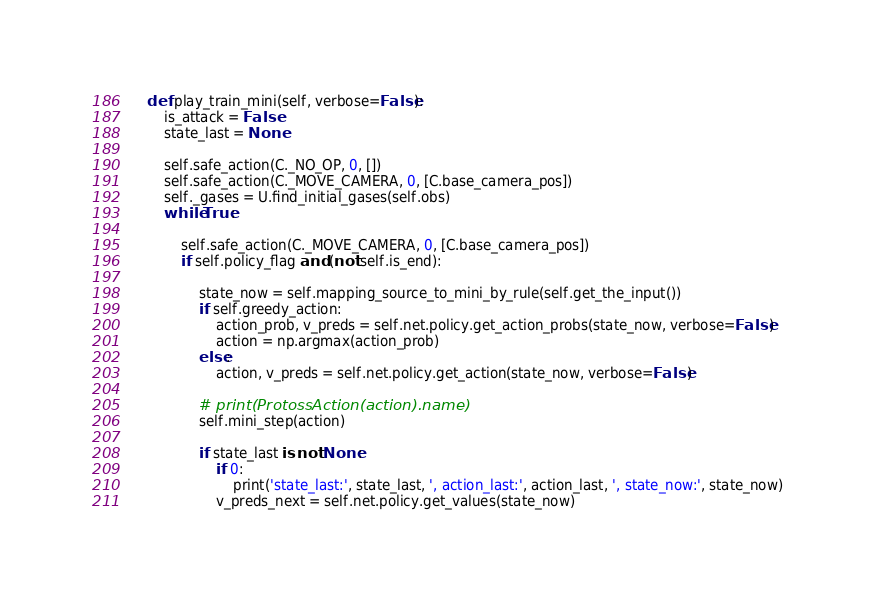<code> <loc_0><loc_0><loc_500><loc_500><_Python_>    def play_train_mini(self, verbose=False):
        is_attack = False
        state_last = None

        self.safe_action(C._NO_OP, 0, [])
        self.safe_action(C._MOVE_CAMERA, 0, [C.base_camera_pos])
        self._gases = U.find_initial_gases(self.obs)
        while True:

            self.safe_action(C._MOVE_CAMERA, 0, [C.base_camera_pos])
            if self.policy_flag and (not self.is_end):

                state_now = self.mapping_source_to_mini_by_rule(self.get_the_input())
                if self.greedy_action:
                    action_prob, v_preds = self.net.policy.get_action_probs(state_now, verbose=False)
                    action = np.argmax(action_prob)
                else:
                    action, v_preds = self.net.policy.get_action(state_now, verbose=False)

                # print(ProtossAction(action).name)
                self.mini_step(action)

                if state_last is not None:
                    if 0:
                        print('state_last:', state_last, ', action_last:', action_last, ', state_now:', state_now)
                    v_preds_next = self.net.policy.get_values(state_now)</code> 